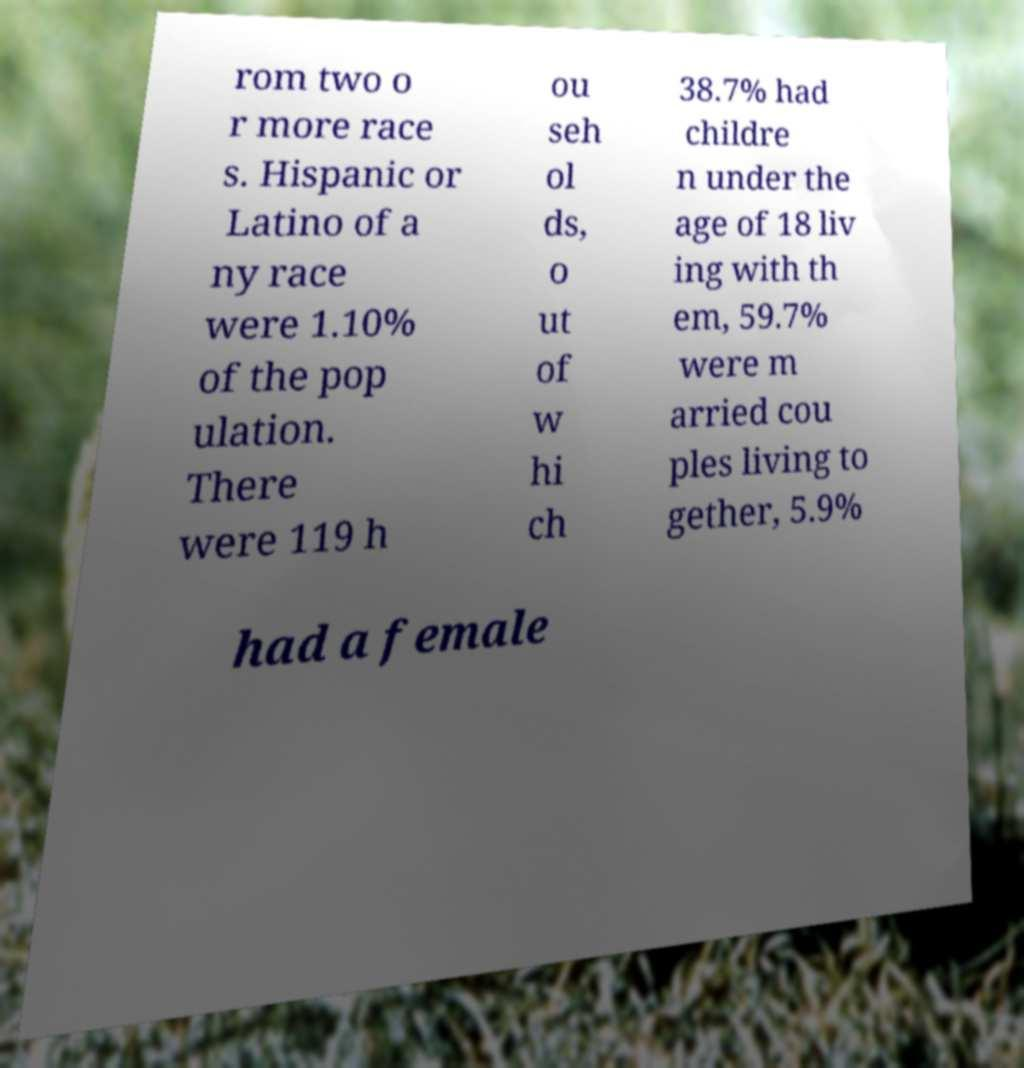Could you assist in decoding the text presented in this image and type it out clearly? rom two o r more race s. Hispanic or Latino of a ny race were 1.10% of the pop ulation. There were 119 h ou seh ol ds, o ut of w hi ch 38.7% had childre n under the age of 18 liv ing with th em, 59.7% were m arried cou ples living to gether, 5.9% had a female 